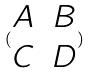<formula> <loc_0><loc_0><loc_500><loc_500>( \begin{matrix} A & B \\ C & D \end{matrix} )</formula> 